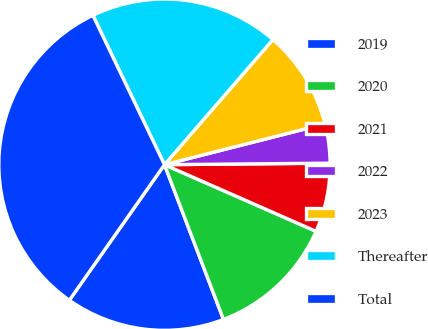Convert chart. <chart><loc_0><loc_0><loc_500><loc_500><pie_chart><fcel>2019<fcel>2020<fcel>2021<fcel>2022<fcel>2023<fcel>Thereafter<fcel>Total<nl><fcel>15.54%<fcel>12.61%<fcel>6.74%<fcel>3.81%<fcel>9.68%<fcel>18.48%<fcel>33.15%<nl></chart> 